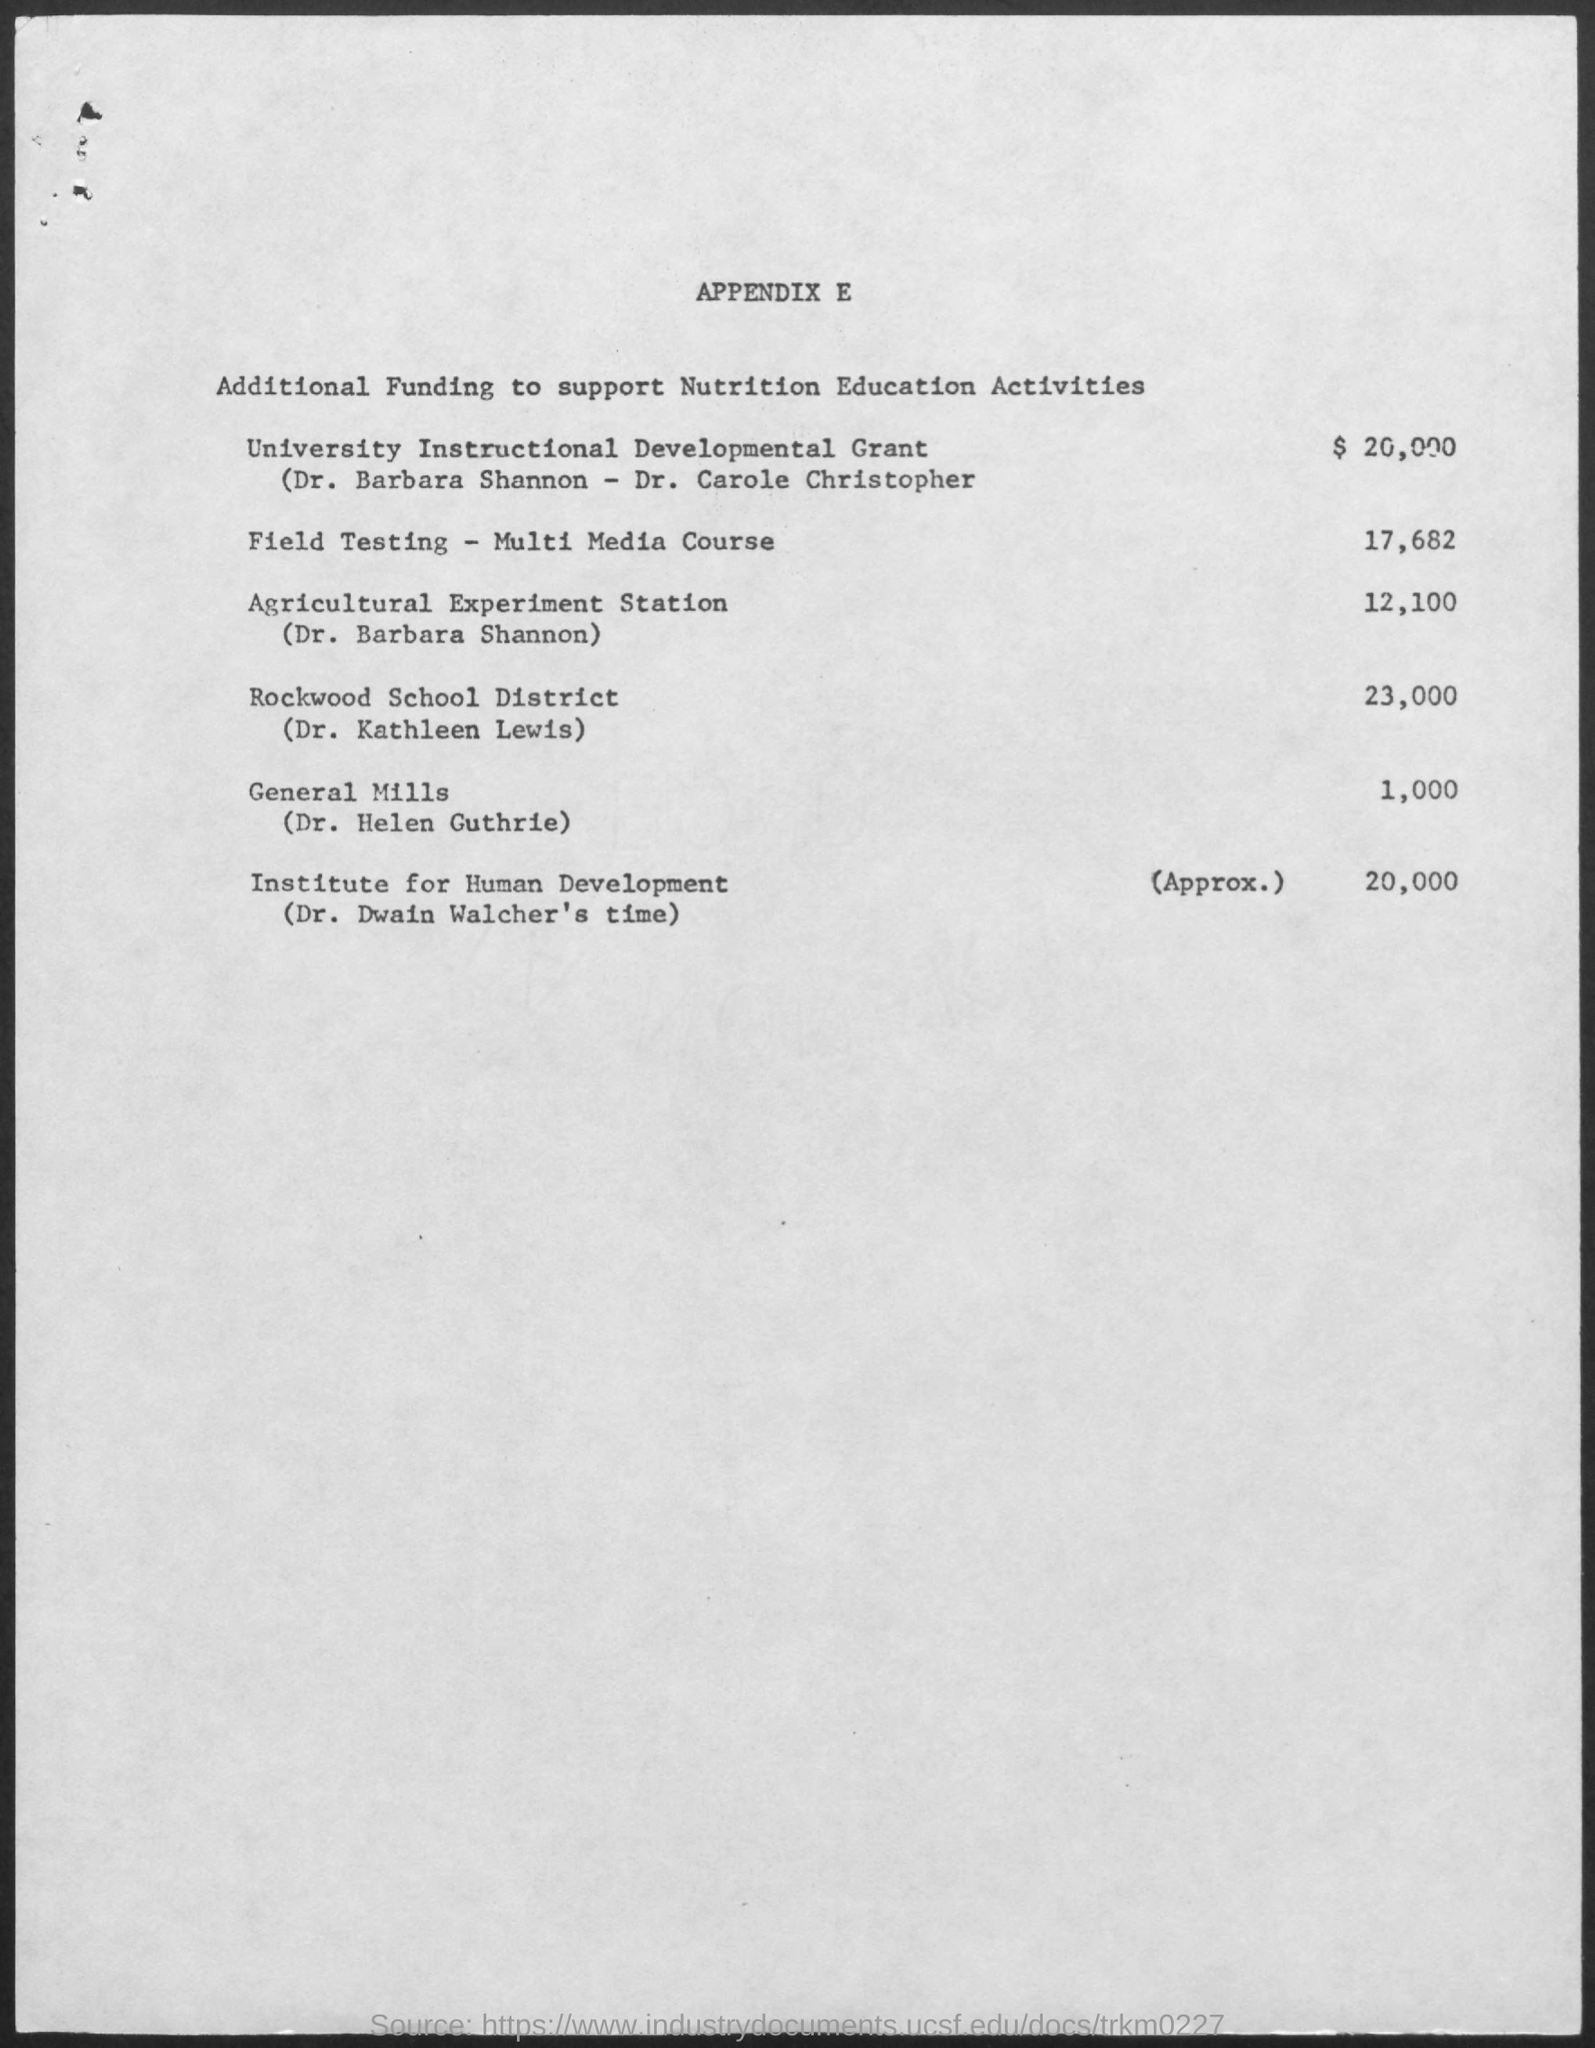Outline some significant characteristics in this image. The cost of Field Testing - Multi media Course is 17,682. The cost of the Agricultural Experiment Station is 12,100. 